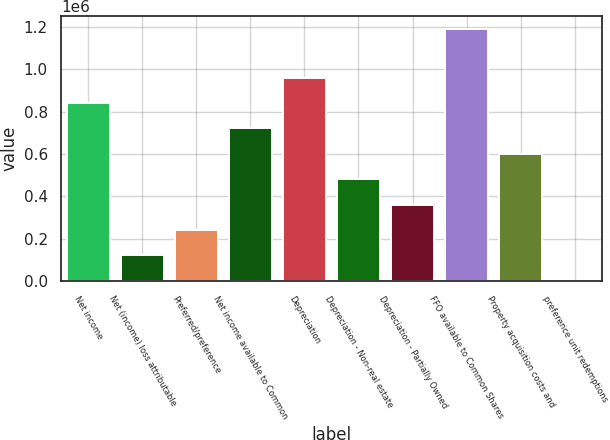Convert chart. <chart><loc_0><loc_0><loc_500><loc_500><bar_chart><fcel>Net income<fcel>Net (income) loss attributable<fcel>Preferred/preference<fcel>Net income available to Common<fcel>Depreciation<fcel>Depreciation - Non-real estate<fcel>Depreciation - Partially Owned<fcel>FFO available to Common Shares<fcel>Property acquisition costs and<fcel>preference unit redemptions<nl><fcel>840747<fcel>121058<fcel>241006<fcel>720799<fcel>960695<fcel>480902<fcel>360954<fcel>1.19092e+06<fcel>600850<fcel>1110<nl></chart> 